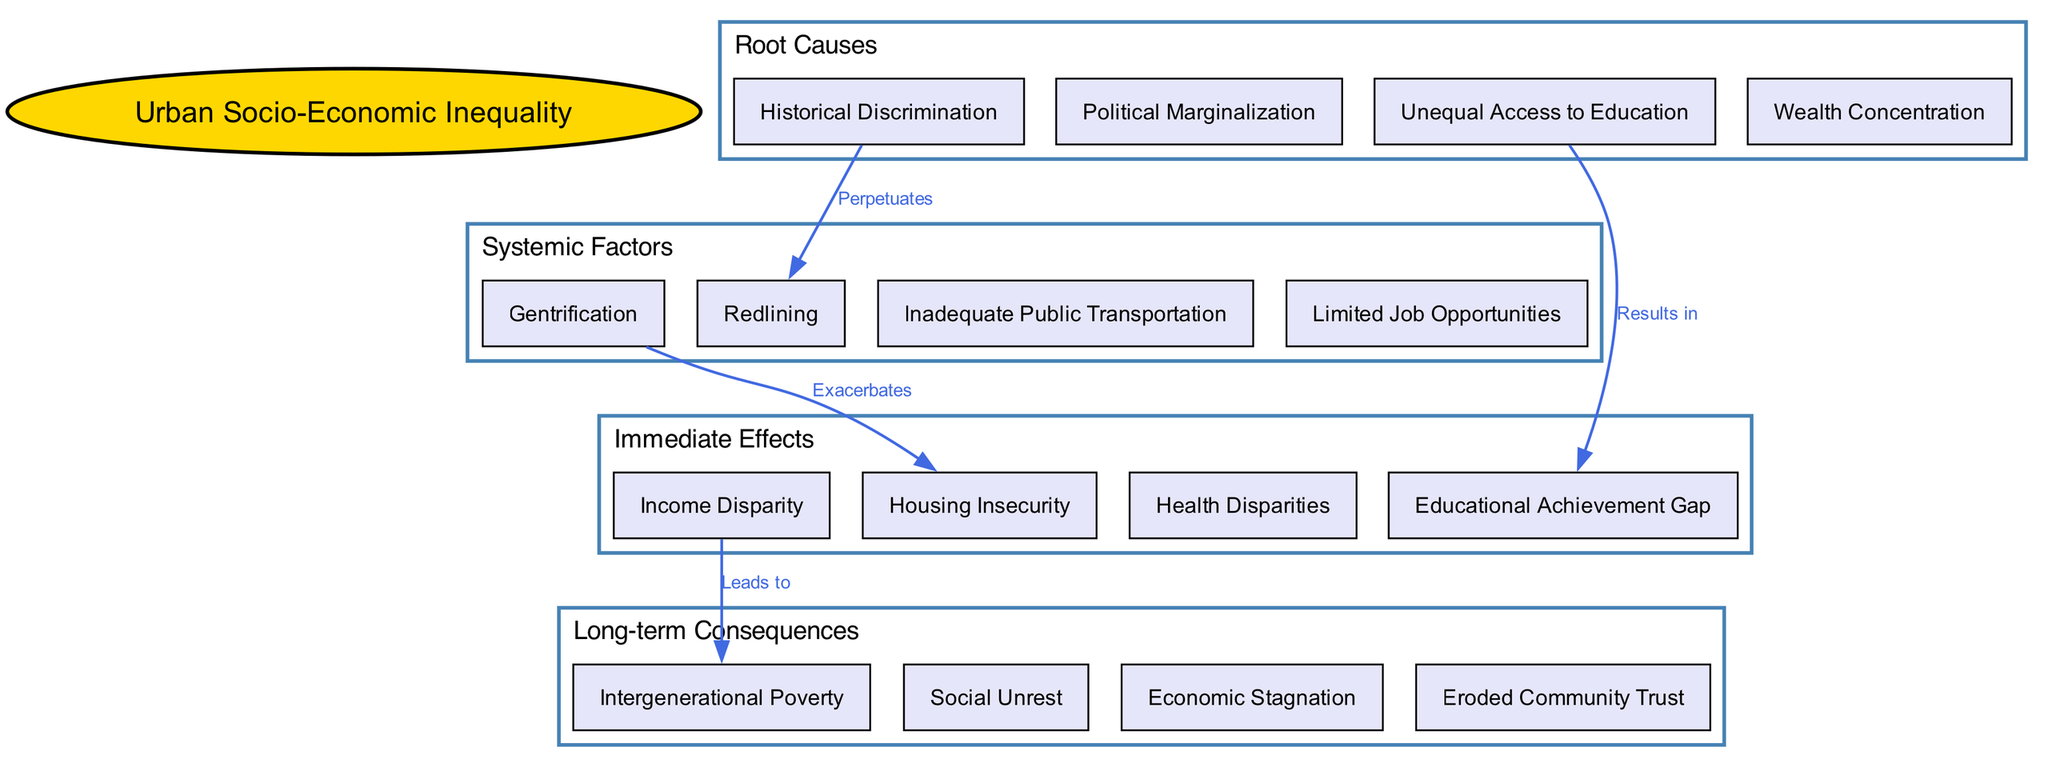What is the central concept depicted in the diagram? The central concept node is labeled "Urban Socio-Economic Inequality", making it the focal point of the diagram.
Answer: Urban Socio-Economic Inequality How many layers are illustrated in the diagram? The diagram contains four distinct layers, named "Root Causes", "Systemic Factors", "Immediate Effects", and "Long-term Consequences".
Answer: 4 What element is connected to "Redlining"? "Historical Discrimination" is identified in the diagram as the element that perpetuates redlining, indicating a direct connection between these two nodes.
Answer: Historical Discrimination Which immediate effect is caused by "Income Disparity"? The diagram indicates that "Income Disparity" leads to "Intergenerational Poverty", establishing a cause-effect relationship between these two elements.
Answer: Intergenerational Poverty What does "Gentrification" exacerbate? The diagram explicitly states that "Gentrification" exacerbates "Housing Insecurity", suggesting a negative impact of gentrification on housing stability.
Answer: Housing Insecurity Which two elements are linked by the label "Results in"? The connection labeled "Results in" links "Unequal Access to Education" and "Educational Achievement Gap", indicating a cause-and-effect relationship between education access and achievement.
Answer: Unequal Access to Education and Educational Achievement Gap What is the relationship between "Health Disparities" and "Immediate Effects"? "Health Disparities" is categorized as one of the immediate effects of systemic socio-economic inequality, showing that it is directly influenced by the factors laid out in the previous layers.
Answer: Immediate Effects How many connections are shown in the diagram? The diagram illustrates four distinct connections that represent various relationships between the elements in different layers, highlighting the complexity of the system.
Answer: 4 What is the purpose of the label "Leads to"? The label "Leads to" indicates a forward causative relationship from one element, in this case, from "Income Disparity" to "Intergenerational Poverty", showing how the former can create the latter over time.
Answer: Causative relationship 